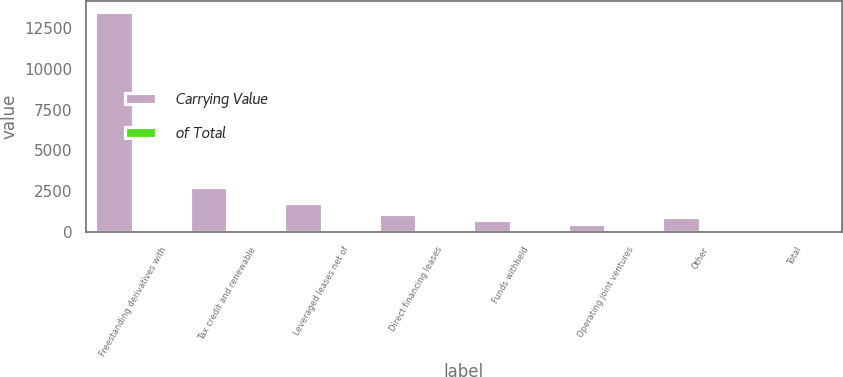Convert chart. <chart><loc_0><loc_0><loc_500><loc_500><stacked_bar_chart><ecel><fcel>Freestanding derivatives with<fcel>Tax credit and renewable<fcel>Leveraged leases net of<fcel>Direct financing leases<fcel>Funds withheld<fcel>Operating joint ventures<fcel>Other<fcel>Total<nl><fcel>Carrying Value<fcel>13452<fcel>2752<fcel>1785<fcel>1119<fcel>763<fcel>513<fcel>899<fcel>100<nl><fcel>of Total<fcel>63.2<fcel>12.9<fcel>8.4<fcel>5.3<fcel>3.6<fcel>2.4<fcel>4.2<fcel>100<nl></chart> 